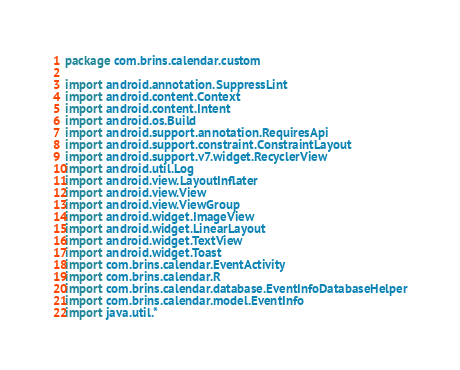<code> <loc_0><loc_0><loc_500><loc_500><_Kotlin_>package com.brins.calendar.custom

import android.annotation.SuppressLint
import android.content.Context
import android.content.Intent
import android.os.Build
import android.support.annotation.RequiresApi
import android.support.constraint.ConstraintLayout
import android.support.v7.widget.RecyclerView
import android.util.Log
import android.view.LayoutInflater
import android.view.View
import android.view.ViewGroup
import android.widget.ImageView
import android.widget.LinearLayout
import android.widget.TextView
import android.widget.Toast
import com.brins.calendar.EventActivity
import com.brins.calendar.R
import com.brins.calendar.database.EventInfoDatabaseHelper
import com.brins.calendar.model.EventInfo
import java.util.*

</code> 